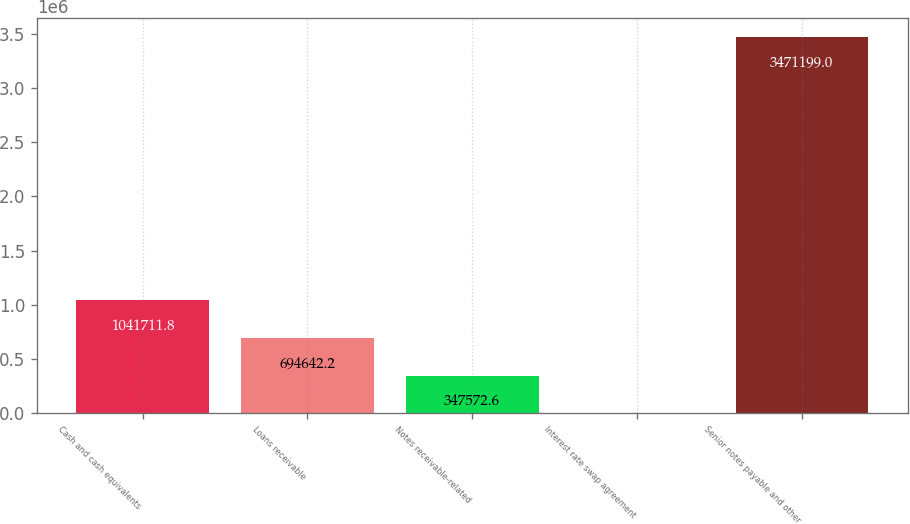<chart> <loc_0><loc_0><loc_500><loc_500><bar_chart><fcel>Cash and cash equivalents<fcel>Loans receivable<fcel>Notes receivable-related<fcel>Interest rate swap agreement<fcel>Senior notes payable and other<nl><fcel>1.04171e+06<fcel>694642<fcel>347573<fcel>503<fcel>3.4712e+06<nl></chart> 